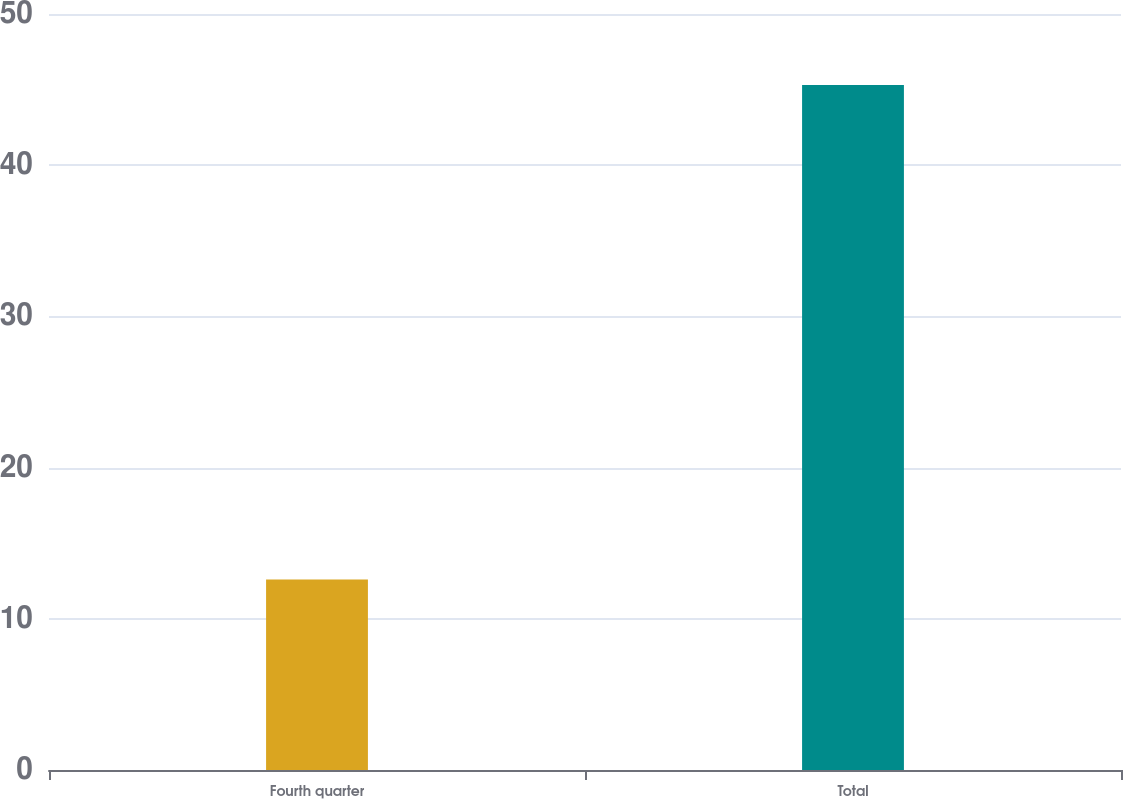Convert chart. <chart><loc_0><loc_0><loc_500><loc_500><bar_chart><fcel>Fourth quarter<fcel>Total<nl><fcel>12.6<fcel>45.3<nl></chart> 